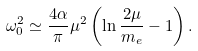Convert formula to latex. <formula><loc_0><loc_0><loc_500><loc_500>\omega _ { 0 } ^ { 2 } \simeq \frac { 4 \alpha } { \pi } \mu ^ { 2 } \left ( \ln \frac { 2 \mu } { m _ { e } } - 1 \right ) .</formula> 